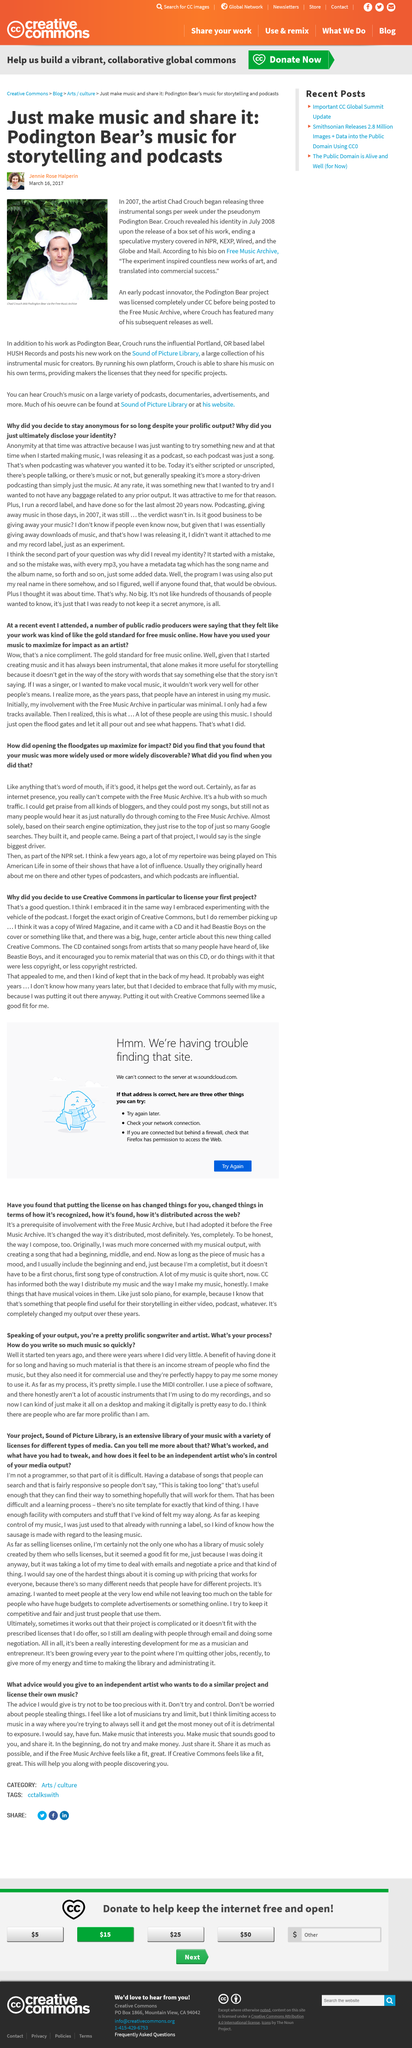Identify some key points in this picture. In the year 2007, Chad Crouch began releasing instrumental songs under the pseudonym Podington Bear. Chad Crouch, also known as Podington Bear, is depicted in the image on the left. Chad Crouch revealed his identity in July 2008. 